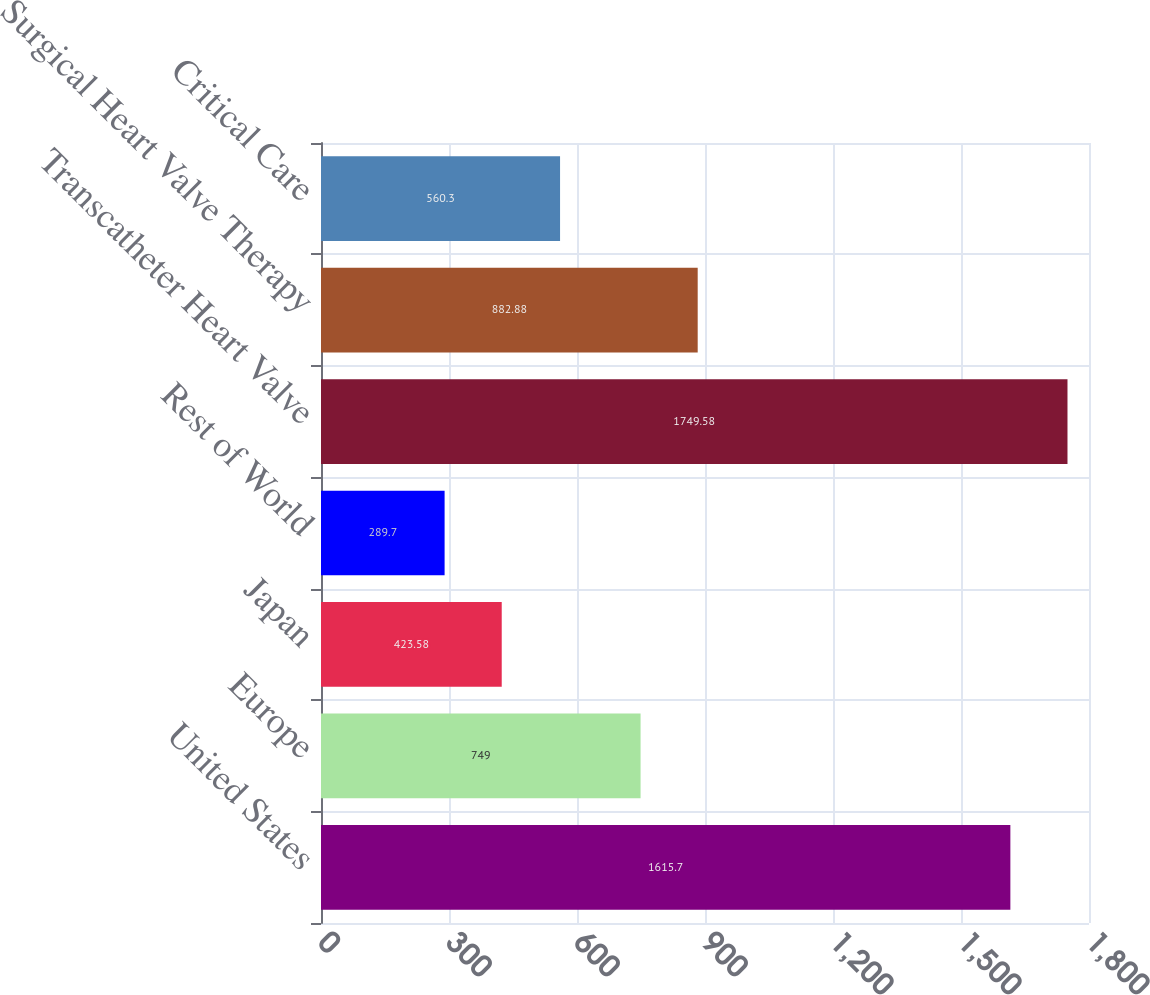<chart> <loc_0><loc_0><loc_500><loc_500><bar_chart><fcel>United States<fcel>Europe<fcel>Japan<fcel>Rest of World<fcel>Transcatheter Heart Valve<fcel>Surgical Heart Valve Therapy<fcel>Critical Care<nl><fcel>1615.7<fcel>749<fcel>423.58<fcel>289.7<fcel>1749.58<fcel>882.88<fcel>560.3<nl></chart> 